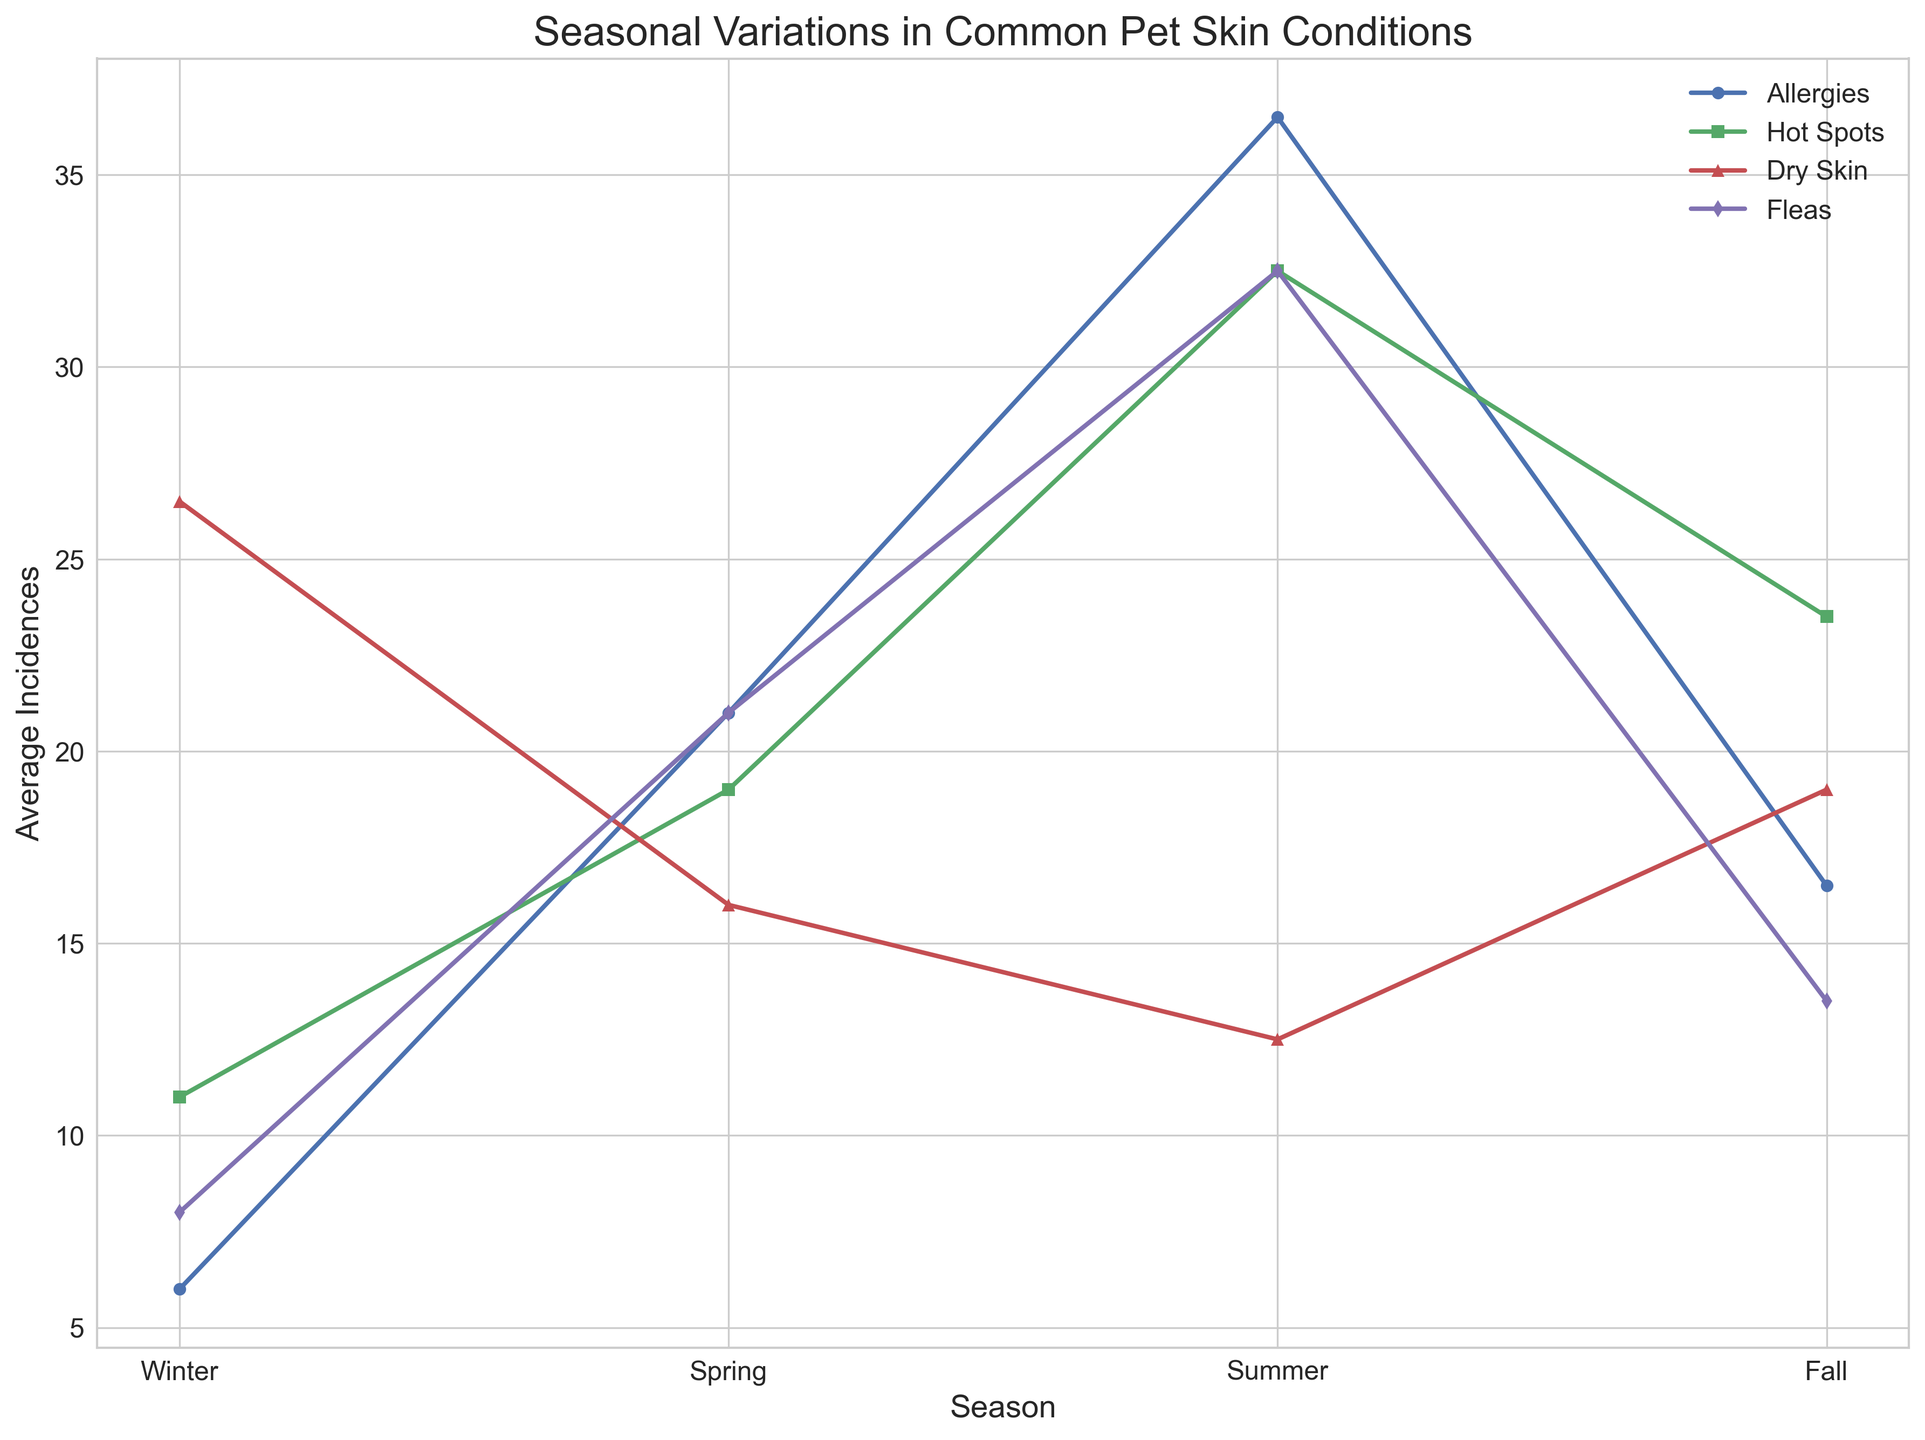Which season has the highest average incidence of allergies? Observing the plot, the path for allergies is noted by circular markers. The highest peak of this path is in Summer.
Answer: Summer How does the average number of hot spots in Spring compare to that in Fall? Looking at the plot, the line representing hot spots has square markers. During Spring, the average incidence is lower compared to Fall.
Answer: Lower What is the difference in average incidences of dry skin between Winter and Summer? The line for dry skin (with triangular markers) shows the highest value in Winter and significantly lower in Summer. Subtracting Summer’s average from Winter’s provides the difference: 26 - 12 = 14.
Answer: 14 Which condition shows the greatest variation across seasons? The highest and lowest points of each condition’s line need to be examined. Allergies exhibit the widest range in the line chart from Winter (6) to Summer (37).
Answer: Allergies What is the sum of average incidences of fleas in Spring and Summer? The line for fleas has diamond markers. Observing their average values in Spring (21) and Summer (32), we sum them: 21 + 32 = 53.
Answer: 53 By how much does the average number of hot spots increase from Winter to Summer? The hot spots line (square markers) starts lower in Winter and peaks at Summer. Subtracting Winter's average from Summer's: 11 - 7 = 4.
Answer: 4 Which condition is most prevalent in Winter? The highest point among the conditions in Winter is for dry skin, indicated by triangular markers.
Answer: Dry Skin Among all the conditions, which one has the least variation across seasons? Observing the lines' peaks and troughs, dry skin shows relatively steady values across all seasons when compared to the others.
Answer: Dry Skin What is the average incidence of allergies over all seasons? Consulting the average incidences of allergies for each season: Winter (6), Spring (21), Summer (37), Fall (17). The average is (6 + 21 + 37 + 17) / 4 = 20.25.
Answer: 20.25 